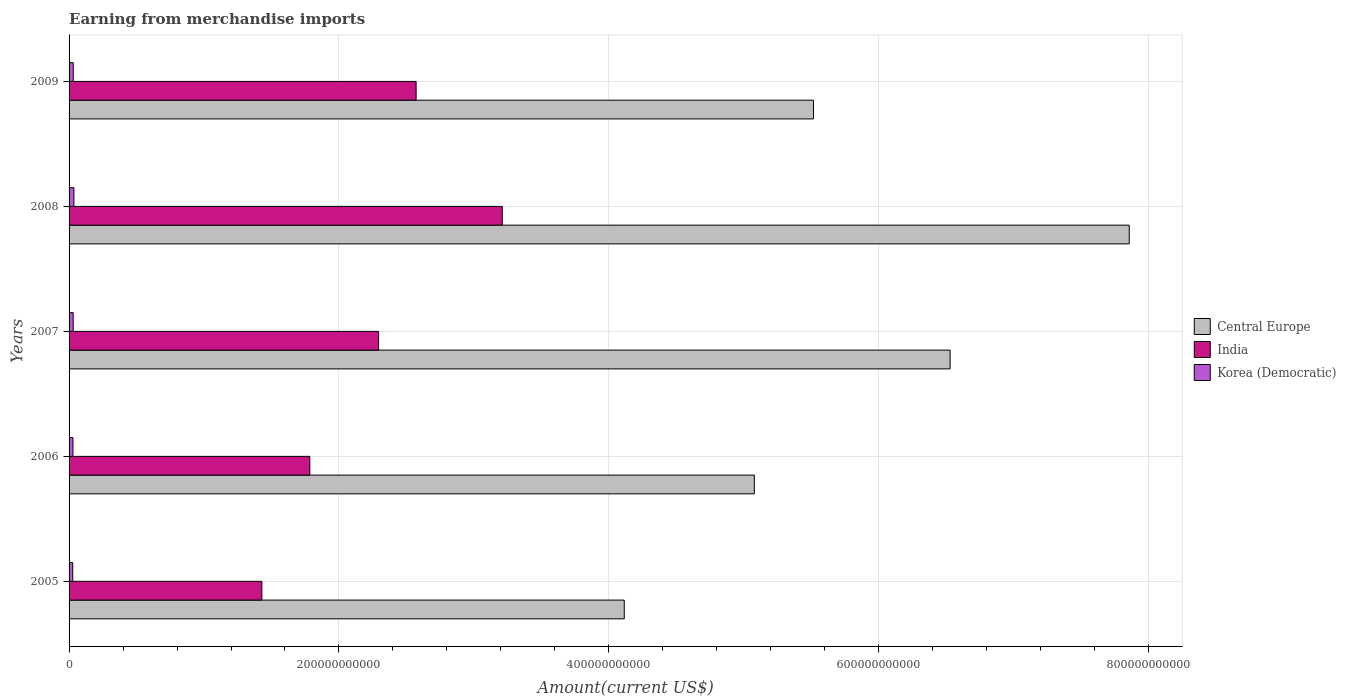How many groups of bars are there?
Your answer should be compact. 5. Are the number of bars on each tick of the Y-axis equal?
Your answer should be very brief. Yes. How many bars are there on the 2nd tick from the top?
Provide a succinct answer. 3. What is the amount earned from merchandise imports in Korea (Democratic) in 2005?
Your answer should be compact. 2.72e+09. Across all years, what is the maximum amount earned from merchandise imports in Central Europe?
Ensure brevity in your answer.  7.86e+11. Across all years, what is the minimum amount earned from merchandise imports in Central Europe?
Ensure brevity in your answer.  4.11e+11. What is the total amount earned from merchandise imports in India in the graph?
Your answer should be compact. 1.13e+12. What is the difference between the amount earned from merchandise imports in India in 2005 and that in 2007?
Your answer should be very brief. -8.65e+1. What is the difference between the amount earned from merchandise imports in Central Europe in 2009 and the amount earned from merchandise imports in Korea (Democratic) in 2007?
Make the answer very short. 5.49e+11. What is the average amount earned from merchandise imports in Central Europe per year?
Give a very brief answer. 5.82e+11. In the year 2007, what is the difference between the amount earned from merchandise imports in Central Europe and amount earned from merchandise imports in India?
Your response must be concise. 4.24e+11. In how many years, is the amount earned from merchandise imports in Korea (Democratic) greater than 520000000000 US$?
Offer a terse response. 0. What is the ratio of the amount earned from merchandise imports in Korea (Democratic) in 2005 to that in 2009?
Give a very brief answer. 0.88. Is the difference between the amount earned from merchandise imports in Central Europe in 2005 and 2009 greater than the difference between the amount earned from merchandise imports in India in 2005 and 2009?
Make the answer very short. No. What is the difference between the highest and the second highest amount earned from merchandise imports in Central Europe?
Make the answer very short. 1.33e+11. What is the difference between the highest and the lowest amount earned from merchandise imports in Central Europe?
Your answer should be very brief. 3.74e+11. Is the sum of the amount earned from merchandise imports in Korea (Democratic) in 2008 and 2009 greater than the maximum amount earned from merchandise imports in India across all years?
Give a very brief answer. No. What does the 2nd bar from the top in 2006 represents?
Offer a very short reply. India. What does the 2nd bar from the bottom in 2008 represents?
Offer a terse response. India. How many bars are there?
Provide a short and direct response. 15. What is the difference between two consecutive major ticks on the X-axis?
Give a very brief answer. 2.00e+11. Are the values on the major ticks of X-axis written in scientific E-notation?
Provide a succinct answer. No. Does the graph contain grids?
Ensure brevity in your answer.  Yes. Where does the legend appear in the graph?
Your answer should be very brief. Center right. How are the legend labels stacked?
Make the answer very short. Vertical. What is the title of the graph?
Your answer should be compact. Earning from merchandise imports. What is the label or title of the X-axis?
Provide a succinct answer. Amount(current US$). What is the Amount(current US$) in Central Europe in 2005?
Offer a very short reply. 4.11e+11. What is the Amount(current US$) of India in 2005?
Keep it short and to the point. 1.43e+11. What is the Amount(current US$) of Korea (Democratic) in 2005?
Offer a terse response. 2.72e+09. What is the Amount(current US$) of Central Europe in 2006?
Make the answer very short. 5.08e+11. What is the Amount(current US$) in India in 2006?
Provide a succinct answer. 1.78e+11. What is the Amount(current US$) in Korea (Democratic) in 2006?
Make the answer very short. 2.88e+09. What is the Amount(current US$) of Central Europe in 2007?
Give a very brief answer. 6.53e+11. What is the Amount(current US$) of India in 2007?
Keep it short and to the point. 2.29e+11. What is the Amount(current US$) of Korea (Democratic) in 2007?
Ensure brevity in your answer.  3.06e+09. What is the Amount(current US$) of Central Europe in 2008?
Provide a short and direct response. 7.86e+11. What is the Amount(current US$) of India in 2008?
Your answer should be very brief. 3.21e+11. What is the Amount(current US$) of Korea (Democratic) in 2008?
Provide a short and direct response. 3.58e+09. What is the Amount(current US$) of Central Europe in 2009?
Keep it short and to the point. 5.52e+11. What is the Amount(current US$) in India in 2009?
Offer a terse response. 2.57e+11. What is the Amount(current US$) of Korea (Democratic) in 2009?
Offer a terse response. 3.10e+09. Across all years, what is the maximum Amount(current US$) of Central Europe?
Your answer should be compact. 7.86e+11. Across all years, what is the maximum Amount(current US$) of India?
Your response must be concise. 3.21e+11. Across all years, what is the maximum Amount(current US$) of Korea (Democratic)?
Provide a short and direct response. 3.58e+09. Across all years, what is the minimum Amount(current US$) in Central Europe?
Make the answer very short. 4.11e+11. Across all years, what is the minimum Amount(current US$) of India?
Offer a terse response. 1.43e+11. Across all years, what is the minimum Amount(current US$) in Korea (Democratic)?
Your response must be concise. 2.72e+09. What is the total Amount(current US$) of Central Europe in the graph?
Ensure brevity in your answer.  2.91e+12. What is the total Amount(current US$) in India in the graph?
Give a very brief answer. 1.13e+12. What is the total Amount(current US$) of Korea (Democratic) in the graph?
Keep it short and to the point. 1.53e+1. What is the difference between the Amount(current US$) of Central Europe in 2005 and that in 2006?
Your answer should be compact. -9.64e+1. What is the difference between the Amount(current US$) of India in 2005 and that in 2006?
Provide a short and direct response. -3.55e+1. What is the difference between the Amount(current US$) of Korea (Democratic) in 2005 and that in 2006?
Keep it short and to the point. -1.62e+08. What is the difference between the Amount(current US$) of Central Europe in 2005 and that in 2007?
Your response must be concise. -2.41e+11. What is the difference between the Amount(current US$) in India in 2005 and that in 2007?
Provide a succinct answer. -8.65e+1. What is the difference between the Amount(current US$) of Korea (Democratic) in 2005 and that in 2007?
Your answer should be compact. -3.37e+08. What is the difference between the Amount(current US$) in Central Europe in 2005 and that in 2008?
Your response must be concise. -3.74e+11. What is the difference between the Amount(current US$) in India in 2005 and that in 2008?
Give a very brief answer. -1.78e+11. What is the difference between the Amount(current US$) in Korea (Democratic) in 2005 and that in 2008?
Your response must be concise. -8.62e+08. What is the difference between the Amount(current US$) of Central Europe in 2005 and that in 2009?
Ensure brevity in your answer.  -1.40e+11. What is the difference between the Amount(current US$) in India in 2005 and that in 2009?
Offer a terse response. -1.14e+11. What is the difference between the Amount(current US$) of Korea (Democratic) in 2005 and that in 2009?
Your response must be concise. -3.77e+08. What is the difference between the Amount(current US$) of Central Europe in 2006 and that in 2007?
Provide a succinct answer. -1.45e+11. What is the difference between the Amount(current US$) in India in 2006 and that in 2007?
Offer a terse response. -5.10e+1. What is the difference between the Amount(current US$) of Korea (Democratic) in 2006 and that in 2007?
Provide a short and direct response. -1.75e+08. What is the difference between the Amount(current US$) of Central Europe in 2006 and that in 2008?
Keep it short and to the point. -2.78e+11. What is the difference between the Amount(current US$) in India in 2006 and that in 2008?
Keep it short and to the point. -1.43e+11. What is the difference between the Amount(current US$) of Korea (Democratic) in 2006 and that in 2008?
Provide a succinct answer. -7.00e+08. What is the difference between the Amount(current US$) in Central Europe in 2006 and that in 2009?
Ensure brevity in your answer.  -4.38e+1. What is the difference between the Amount(current US$) of India in 2006 and that in 2009?
Keep it short and to the point. -7.88e+1. What is the difference between the Amount(current US$) in Korea (Democratic) in 2006 and that in 2009?
Give a very brief answer. -2.15e+08. What is the difference between the Amount(current US$) in Central Europe in 2007 and that in 2008?
Your answer should be very brief. -1.33e+11. What is the difference between the Amount(current US$) of India in 2007 and that in 2008?
Your answer should be very brief. -9.17e+1. What is the difference between the Amount(current US$) in Korea (Democratic) in 2007 and that in 2008?
Keep it short and to the point. -5.25e+08. What is the difference between the Amount(current US$) of Central Europe in 2007 and that in 2009?
Make the answer very short. 1.01e+11. What is the difference between the Amount(current US$) of India in 2007 and that in 2009?
Provide a succinct answer. -2.78e+1. What is the difference between the Amount(current US$) in Korea (Democratic) in 2007 and that in 2009?
Your answer should be very brief. -4.00e+07. What is the difference between the Amount(current US$) of Central Europe in 2008 and that in 2009?
Your response must be concise. 2.34e+11. What is the difference between the Amount(current US$) of India in 2008 and that in 2009?
Your answer should be very brief. 6.38e+1. What is the difference between the Amount(current US$) of Korea (Democratic) in 2008 and that in 2009?
Your answer should be compact. 4.85e+08. What is the difference between the Amount(current US$) in Central Europe in 2005 and the Amount(current US$) in India in 2006?
Offer a terse response. 2.33e+11. What is the difference between the Amount(current US$) of Central Europe in 2005 and the Amount(current US$) of Korea (Democratic) in 2006?
Make the answer very short. 4.09e+11. What is the difference between the Amount(current US$) in India in 2005 and the Amount(current US$) in Korea (Democratic) in 2006?
Your response must be concise. 1.40e+11. What is the difference between the Amount(current US$) in Central Europe in 2005 and the Amount(current US$) in India in 2007?
Your response must be concise. 1.82e+11. What is the difference between the Amount(current US$) of Central Europe in 2005 and the Amount(current US$) of Korea (Democratic) in 2007?
Provide a succinct answer. 4.08e+11. What is the difference between the Amount(current US$) in India in 2005 and the Amount(current US$) in Korea (Democratic) in 2007?
Ensure brevity in your answer.  1.40e+11. What is the difference between the Amount(current US$) of Central Europe in 2005 and the Amount(current US$) of India in 2008?
Offer a terse response. 9.04e+1. What is the difference between the Amount(current US$) in Central Europe in 2005 and the Amount(current US$) in Korea (Democratic) in 2008?
Keep it short and to the point. 4.08e+11. What is the difference between the Amount(current US$) in India in 2005 and the Amount(current US$) in Korea (Democratic) in 2008?
Make the answer very short. 1.39e+11. What is the difference between the Amount(current US$) in Central Europe in 2005 and the Amount(current US$) in India in 2009?
Offer a very short reply. 1.54e+11. What is the difference between the Amount(current US$) of Central Europe in 2005 and the Amount(current US$) of Korea (Democratic) in 2009?
Your response must be concise. 4.08e+11. What is the difference between the Amount(current US$) in India in 2005 and the Amount(current US$) in Korea (Democratic) in 2009?
Offer a terse response. 1.40e+11. What is the difference between the Amount(current US$) in Central Europe in 2006 and the Amount(current US$) in India in 2007?
Ensure brevity in your answer.  2.78e+11. What is the difference between the Amount(current US$) of Central Europe in 2006 and the Amount(current US$) of Korea (Democratic) in 2007?
Offer a very short reply. 5.05e+11. What is the difference between the Amount(current US$) in India in 2006 and the Amount(current US$) in Korea (Democratic) in 2007?
Offer a very short reply. 1.75e+11. What is the difference between the Amount(current US$) in Central Europe in 2006 and the Amount(current US$) in India in 2008?
Keep it short and to the point. 1.87e+11. What is the difference between the Amount(current US$) of Central Europe in 2006 and the Amount(current US$) of Korea (Democratic) in 2008?
Provide a succinct answer. 5.04e+11. What is the difference between the Amount(current US$) of India in 2006 and the Amount(current US$) of Korea (Democratic) in 2008?
Keep it short and to the point. 1.75e+11. What is the difference between the Amount(current US$) in Central Europe in 2006 and the Amount(current US$) in India in 2009?
Give a very brief answer. 2.51e+11. What is the difference between the Amount(current US$) of Central Europe in 2006 and the Amount(current US$) of Korea (Democratic) in 2009?
Your answer should be very brief. 5.05e+11. What is the difference between the Amount(current US$) of India in 2006 and the Amount(current US$) of Korea (Democratic) in 2009?
Make the answer very short. 1.75e+11. What is the difference between the Amount(current US$) of Central Europe in 2007 and the Amount(current US$) of India in 2008?
Offer a terse response. 3.32e+11. What is the difference between the Amount(current US$) of Central Europe in 2007 and the Amount(current US$) of Korea (Democratic) in 2008?
Provide a succinct answer. 6.49e+11. What is the difference between the Amount(current US$) in India in 2007 and the Amount(current US$) in Korea (Democratic) in 2008?
Your response must be concise. 2.26e+11. What is the difference between the Amount(current US$) in Central Europe in 2007 and the Amount(current US$) in India in 2009?
Ensure brevity in your answer.  3.96e+11. What is the difference between the Amount(current US$) in Central Europe in 2007 and the Amount(current US$) in Korea (Democratic) in 2009?
Offer a terse response. 6.50e+11. What is the difference between the Amount(current US$) in India in 2007 and the Amount(current US$) in Korea (Democratic) in 2009?
Make the answer very short. 2.26e+11. What is the difference between the Amount(current US$) of Central Europe in 2008 and the Amount(current US$) of India in 2009?
Keep it short and to the point. 5.28e+11. What is the difference between the Amount(current US$) in Central Europe in 2008 and the Amount(current US$) in Korea (Democratic) in 2009?
Your response must be concise. 7.83e+11. What is the difference between the Amount(current US$) of India in 2008 and the Amount(current US$) of Korea (Democratic) in 2009?
Your answer should be compact. 3.18e+11. What is the average Amount(current US$) of Central Europe per year?
Give a very brief answer. 5.82e+11. What is the average Amount(current US$) in India per year?
Give a very brief answer. 2.26e+11. What is the average Amount(current US$) in Korea (Democratic) per year?
Offer a terse response. 3.07e+09. In the year 2005, what is the difference between the Amount(current US$) in Central Europe and Amount(current US$) in India?
Your answer should be very brief. 2.69e+11. In the year 2005, what is the difference between the Amount(current US$) in Central Europe and Amount(current US$) in Korea (Democratic)?
Give a very brief answer. 4.09e+11. In the year 2005, what is the difference between the Amount(current US$) of India and Amount(current US$) of Korea (Democratic)?
Your answer should be very brief. 1.40e+11. In the year 2006, what is the difference between the Amount(current US$) of Central Europe and Amount(current US$) of India?
Your answer should be compact. 3.29e+11. In the year 2006, what is the difference between the Amount(current US$) in Central Europe and Amount(current US$) in Korea (Democratic)?
Offer a terse response. 5.05e+11. In the year 2006, what is the difference between the Amount(current US$) of India and Amount(current US$) of Korea (Democratic)?
Offer a very short reply. 1.76e+11. In the year 2007, what is the difference between the Amount(current US$) of Central Europe and Amount(current US$) of India?
Keep it short and to the point. 4.24e+11. In the year 2007, what is the difference between the Amount(current US$) in Central Europe and Amount(current US$) in Korea (Democratic)?
Your answer should be very brief. 6.50e+11. In the year 2007, what is the difference between the Amount(current US$) of India and Amount(current US$) of Korea (Democratic)?
Ensure brevity in your answer.  2.26e+11. In the year 2008, what is the difference between the Amount(current US$) in Central Europe and Amount(current US$) in India?
Provide a short and direct response. 4.65e+11. In the year 2008, what is the difference between the Amount(current US$) of Central Europe and Amount(current US$) of Korea (Democratic)?
Your answer should be compact. 7.82e+11. In the year 2008, what is the difference between the Amount(current US$) of India and Amount(current US$) of Korea (Democratic)?
Offer a very short reply. 3.17e+11. In the year 2009, what is the difference between the Amount(current US$) in Central Europe and Amount(current US$) in India?
Keep it short and to the point. 2.94e+11. In the year 2009, what is the difference between the Amount(current US$) in Central Europe and Amount(current US$) in Korea (Democratic)?
Give a very brief answer. 5.49e+11. In the year 2009, what is the difference between the Amount(current US$) in India and Amount(current US$) in Korea (Democratic)?
Provide a succinct answer. 2.54e+11. What is the ratio of the Amount(current US$) in Central Europe in 2005 to that in 2006?
Make the answer very short. 0.81. What is the ratio of the Amount(current US$) of India in 2005 to that in 2006?
Give a very brief answer. 0.8. What is the ratio of the Amount(current US$) of Korea (Democratic) in 2005 to that in 2006?
Offer a terse response. 0.94. What is the ratio of the Amount(current US$) in Central Europe in 2005 to that in 2007?
Give a very brief answer. 0.63. What is the ratio of the Amount(current US$) in India in 2005 to that in 2007?
Offer a terse response. 0.62. What is the ratio of the Amount(current US$) in Korea (Democratic) in 2005 to that in 2007?
Give a very brief answer. 0.89. What is the ratio of the Amount(current US$) of Central Europe in 2005 to that in 2008?
Provide a succinct answer. 0.52. What is the ratio of the Amount(current US$) of India in 2005 to that in 2008?
Your response must be concise. 0.45. What is the ratio of the Amount(current US$) of Korea (Democratic) in 2005 to that in 2008?
Your response must be concise. 0.76. What is the ratio of the Amount(current US$) in Central Europe in 2005 to that in 2009?
Your answer should be very brief. 0.75. What is the ratio of the Amount(current US$) in India in 2005 to that in 2009?
Provide a succinct answer. 0.56. What is the ratio of the Amount(current US$) of Korea (Democratic) in 2005 to that in 2009?
Keep it short and to the point. 0.88. What is the ratio of the Amount(current US$) of India in 2006 to that in 2007?
Offer a terse response. 0.78. What is the ratio of the Amount(current US$) in Korea (Democratic) in 2006 to that in 2007?
Keep it short and to the point. 0.94. What is the ratio of the Amount(current US$) in Central Europe in 2006 to that in 2008?
Make the answer very short. 0.65. What is the ratio of the Amount(current US$) in India in 2006 to that in 2008?
Ensure brevity in your answer.  0.56. What is the ratio of the Amount(current US$) of Korea (Democratic) in 2006 to that in 2008?
Offer a terse response. 0.8. What is the ratio of the Amount(current US$) of Central Europe in 2006 to that in 2009?
Your response must be concise. 0.92. What is the ratio of the Amount(current US$) in India in 2006 to that in 2009?
Make the answer very short. 0.69. What is the ratio of the Amount(current US$) in Korea (Democratic) in 2006 to that in 2009?
Provide a short and direct response. 0.93. What is the ratio of the Amount(current US$) of Central Europe in 2007 to that in 2008?
Provide a short and direct response. 0.83. What is the ratio of the Amount(current US$) of India in 2007 to that in 2008?
Provide a short and direct response. 0.71. What is the ratio of the Amount(current US$) of Korea (Democratic) in 2007 to that in 2008?
Provide a succinct answer. 0.85. What is the ratio of the Amount(current US$) of Central Europe in 2007 to that in 2009?
Give a very brief answer. 1.18. What is the ratio of the Amount(current US$) of India in 2007 to that in 2009?
Make the answer very short. 0.89. What is the ratio of the Amount(current US$) of Korea (Democratic) in 2007 to that in 2009?
Your answer should be compact. 0.99. What is the ratio of the Amount(current US$) in Central Europe in 2008 to that in 2009?
Give a very brief answer. 1.42. What is the ratio of the Amount(current US$) in India in 2008 to that in 2009?
Provide a short and direct response. 1.25. What is the ratio of the Amount(current US$) of Korea (Democratic) in 2008 to that in 2009?
Offer a terse response. 1.16. What is the difference between the highest and the second highest Amount(current US$) in Central Europe?
Your response must be concise. 1.33e+11. What is the difference between the highest and the second highest Amount(current US$) of India?
Provide a succinct answer. 6.38e+1. What is the difference between the highest and the second highest Amount(current US$) of Korea (Democratic)?
Make the answer very short. 4.85e+08. What is the difference between the highest and the lowest Amount(current US$) of Central Europe?
Your answer should be compact. 3.74e+11. What is the difference between the highest and the lowest Amount(current US$) of India?
Your response must be concise. 1.78e+11. What is the difference between the highest and the lowest Amount(current US$) in Korea (Democratic)?
Your response must be concise. 8.62e+08. 